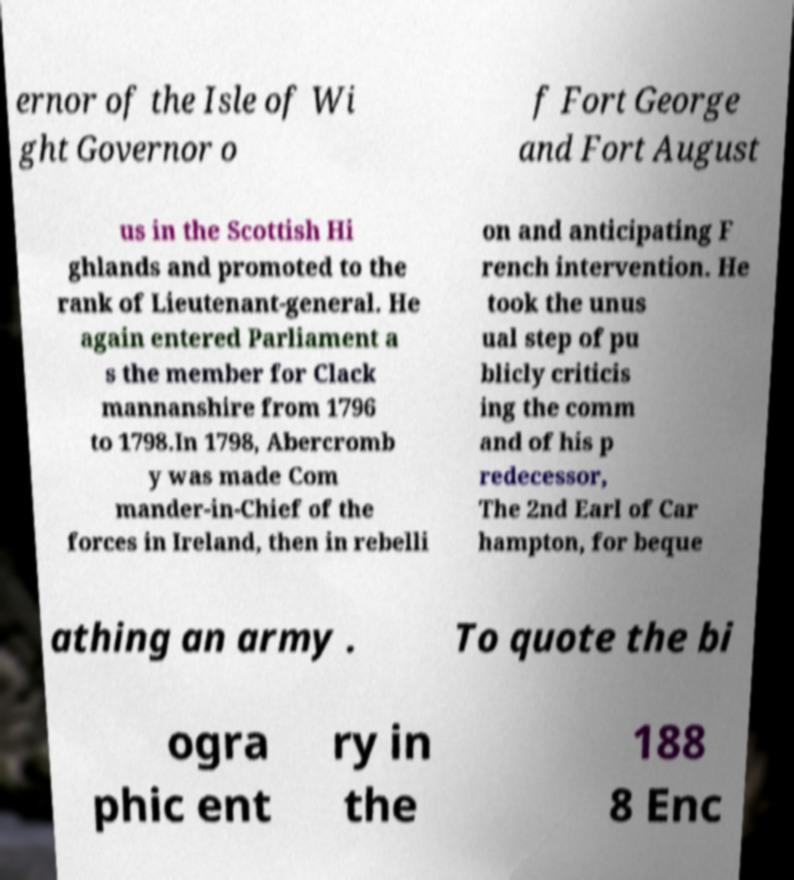Could you assist in decoding the text presented in this image and type it out clearly? ernor of the Isle of Wi ght Governor o f Fort George and Fort August us in the Scottish Hi ghlands and promoted to the rank of Lieutenant-general. He again entered Parliament a s the member for Clack mannanshire from 1796 to 1798.In 1798, Abercromb y was made Com mander-in-Chief of the forces in Ireland, then in rebelli on and anticipating F rench intervention. He took the unus ual step of pu blicly criticis ing the comm and of his p redecessor, The 2nd Earl of Car hampton, for beque athing an army . To quote the bi ogra phic ent ry in the 188 8 Enc 